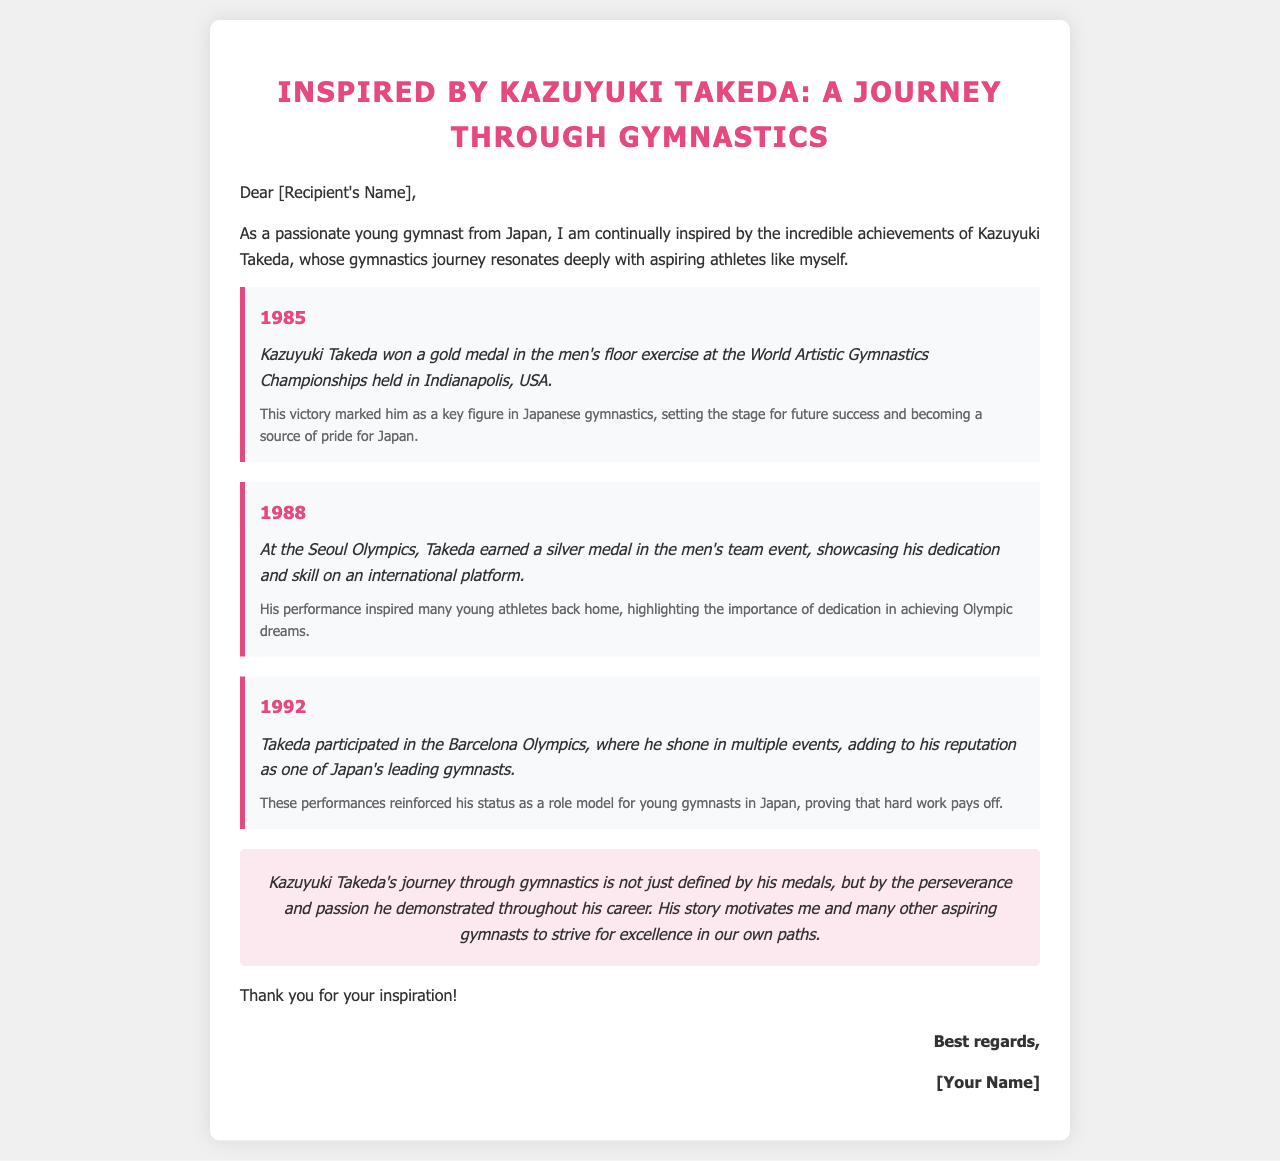What year did Kazuyuki Takeda win a gold medal in the men's floor exercise? The document states that Kazuyuki Takeda won a gold medal in 1985.
Answer: 1985 What medal did Kazuyuki Takeda win at the Seoul Olympics? The document mentions that Takeda earned a silver medal in the men's team event at the Seoul Olympics.
Answer: Silver In which year did Kazuyuki Takeda participate in the Barcelona Olympics? The document specifies that Takeda participated in the Barcelona Olympics in 1992.
Answer: 1992 What was the location of the 1985 World Artistic Gymnastics Championships? According to the document, the championships were held in Indianapolis, USA.
Answer: Indianapolis, USA How did Takeda's achievements impact young athletes in Japan? The document highlights that his performances inspired many young athletes back home, emphasizing the importance of dedication.
Answer: Inspired young athletes What key milestone is associated with the year 1988 for Kazuyuki Takeda? The document notes that in 1988, Takeda earned a silver medal in the men's team event at the Seoul Olympics.
Answer: Silver medal at the Seoul Olympics What does Kazuyuki Takeda's journey through gymnastics symbolize in the document? The document states that his journey is defined by perseverance and passion, motivating aspiring gymnasts.
Answer: Perseverance and passion What is the tone of the conclusion in the email? The conclusion reflects a motivational and inspiring tone regarding Takeda's achievements and influence.
Answer: Motivational 